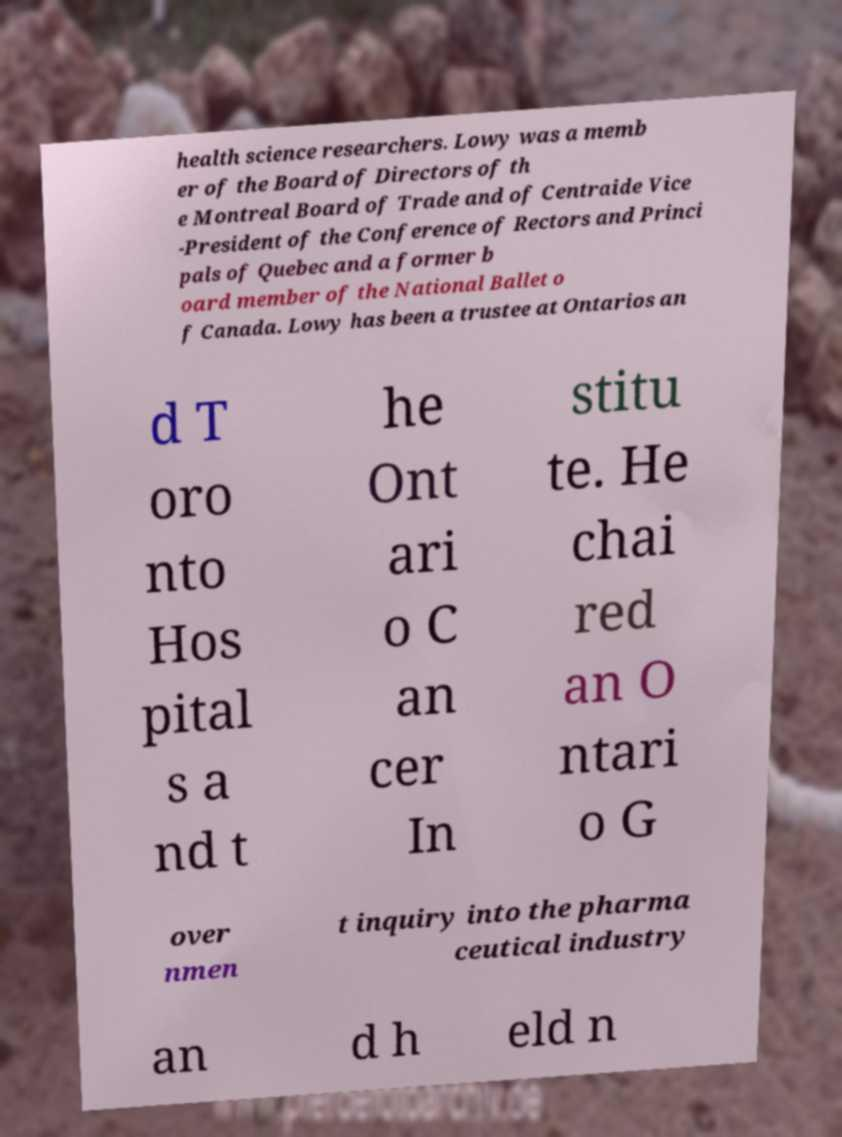For documentation purposes, I need the text within this image transcribed. Could you provide that? health science researchers. Lowy was a memb er of the Board of Directors of th e Montreal Board of Trade and of Centraide Vice -President of the Conference of Rectors and Princi pals of Quebec and a former b oard member of the National Ballet o f Canada. Lowy has been a trustee at Ontarios an d T oro nto Hos pital s a nd t he Ont ari o C an cer In stitu te. He chai red an O ntari o G over nmen t inquiry into the pharma ceutical industry an d h eld n 